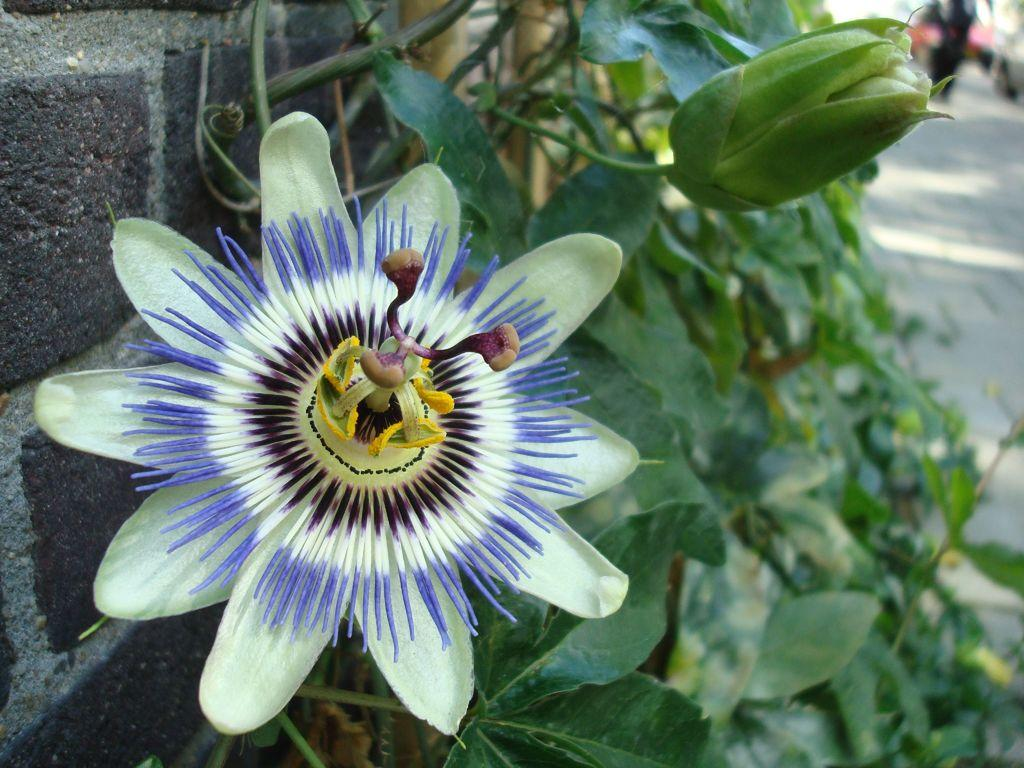What type of plant is visible in the image? There is a flower and a bud on the plant in the image. Where is the plant located in relation to other objects? The plant is near a wall. What can be seen in the background of the image? In the background, there appears to be a person walking on the road. What type of soup is being served in the image? There is no soup present in the image; it features a plant with a flower and a bud near a wall. Can you tell me how many requests the person in the image has made? There is no person making requests in the image; it only shows a plant and a person walking in the background. 